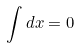Convert formula to latex. <formula><loc_0><loc_0><loc_500><loc_500>\int d x = 0</formula> 